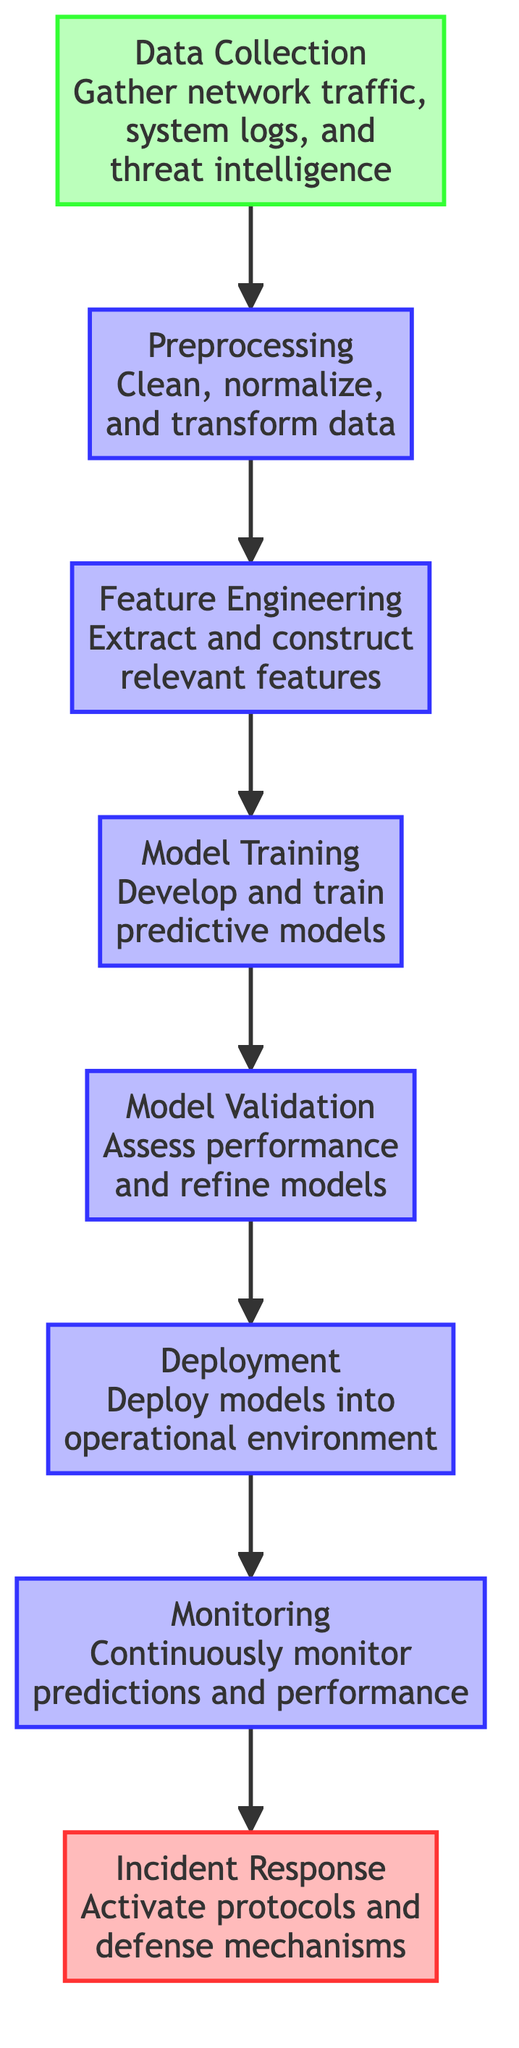What is the first step in the flow chart? The diagram begins with "Data Collection," which is the first node in the process. This is indicated by the arrows flowing upward.
Answer: Data Collection How many nodes are there in the diagram? By counting all the individual components from "Data Collection" to "Incident Response," we find there are a total of eight distinct nodes.
Answer: Eight What is the output of the "Model Validation" step? The output of "Model Validation" connects directly to the "Deployment" step, indicating its outcome is that the model is ready for deployment.
Answer: Deployment Which step comes after "Monitoring"? According to the flow of the diagram, the next step after "Monitoring" is "Incident Response," as shown by the upward arrow leading to it.
Answer: Incident Response What is the purpose of the "Preprocessing" step? The "Preprocessing" step is described as cleaning, normalizing, and transforming the collected data, which prepares it for subsequent processing.
Answer: Clean, normalize, and transform data How does "Feature Engineering" relate to "Model Training"? "Feature Engineering" is a prerequisite for "Model Training," as indicated by the flow arrow connecting them, showing that features need to be engineered before training models.
Answer: Prerequisite What action is taken in the "Incident Response" phase? The description of "Incident Response" states that it involves activating predefined cybersecurity response protocols to deal with a predicted breach.
Answer: Activate protocols What is a key function of the "Monitoring" step? The "Monitoring" step is critical for continuously observing model predictions and system performance, which is essential for adaptive response measures.
Answer: Continuously monitor predictions and performance What is the commonality between the steps "Model Training" and "Model Validation"? Both steps are concerned with developing and assessing predictive models; "Model Training" focuses on development while "Model Validation" focuses on assessment.
Answer: Development and assessment of models 